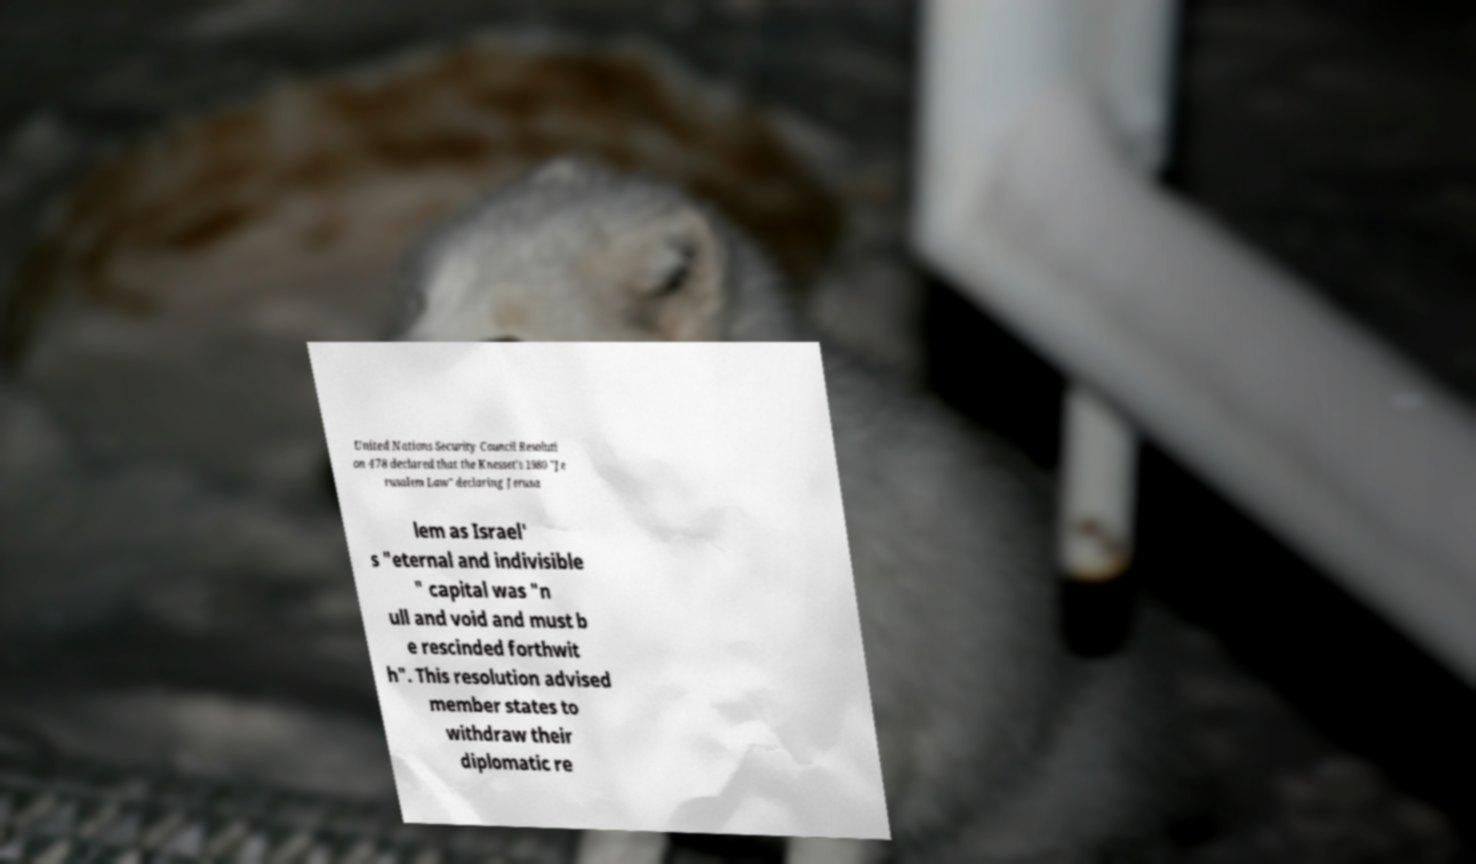I need the written content from this picture converted into text. Can you do that? United Nations Security Council Resoluti on 478 declared that the Knesset's 1980 "Je rusalem Law" declaring Jerusa lem as Israel' s "eternal and indivisible " capital was "n ull and void and must b e rescinded forthwit h". This resolution advised member states to withdraw their diplomatic re 